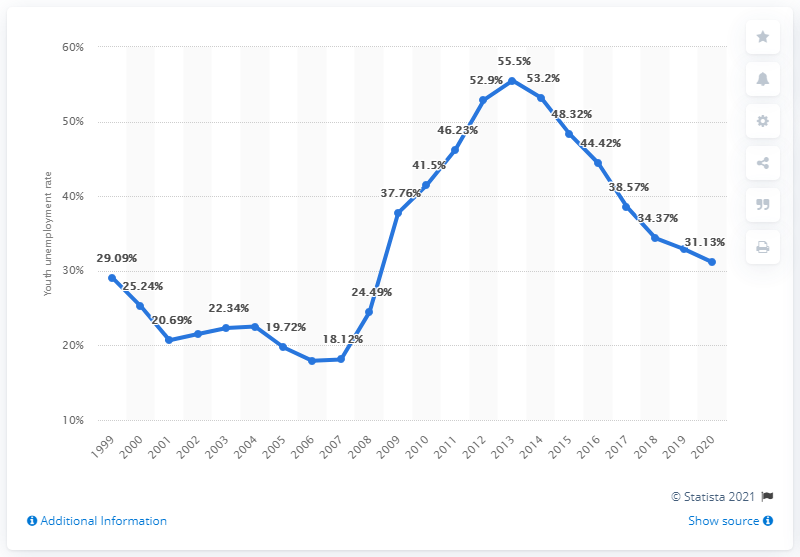Mention a couple of crucial points in this snapshot. The youth unemployment rate in Spain in 2020 was 31.13%. 